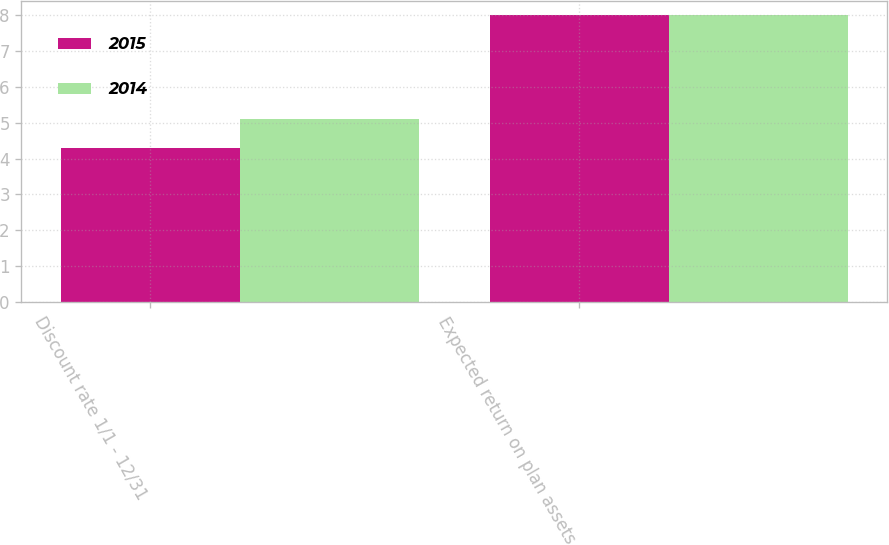Convert chart to OTSL. <chart><loc_0><loc_0><loc_500><loc_500><stacked_bar_chart><ecel><fcel>Discount rate 1/1 - 12/31<fcel>Expected return on plan assets<nl><fcel>2015<fcel>4.3<fcel>8<nl><fcel>2014<fcel>5.1<fcel>8<nl></chart> 